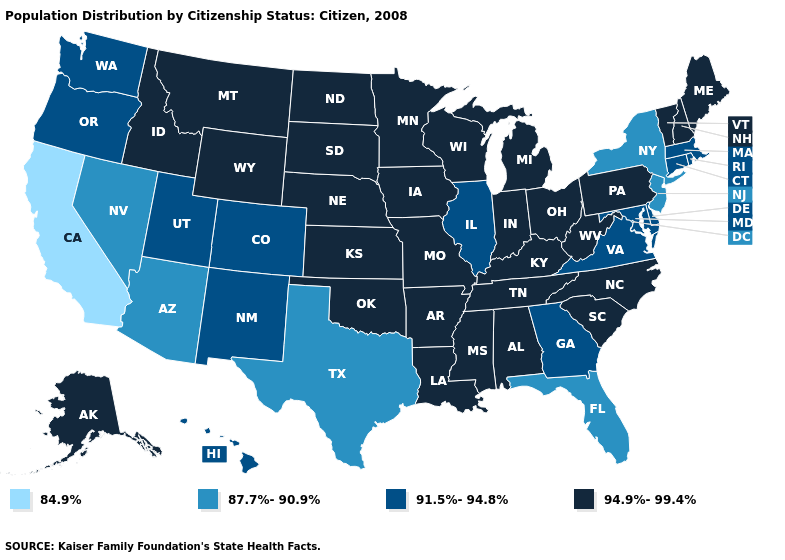Does South Dakota have the lowest value in the USA?
Write a very short answer. No. Does South Carolina have the same value as Alabama?
Be succinct. Yes. Name the states that have a value in the range 84.9%?
Keep it brief. California. Among the states that border Virginia , does Kentucky have the lowest value?
Be succinct. No. Name the states that have a value in the range 87.7%-90.9%?
Concise answer only. Arizona, Florida, Nevada, New Jersey, New York, Texas. What is the lowest value in states that border Florida?
Short answer required. 91.5%-94.8%. Name the states that have a value in the range 87.7%-90.9%?
Quick response, please. Arizona, Florida, Nevada, New Jersey, New York, Texas. What is the value of Arkansas?
Concise answer only. 94.9%-99.4%. Does Massachusetts have the highest value in the Northeast?
Short answer required. No. What is the value of Louisiana?
Give a very brief answer. 94.9%-99.4%. Name the states that have a value in the range 87.7%-90.9%?
Concise answer only. Arizona, Florida, Nevada, New Jersey, New York, Texas. Does Wisconsin have a higher value than New Mexico?
Give a very brief answer. Yes. What is the value of Mississippi?
Write a very short answer. 94.9%-99.4%. Name the states that have a value in the range 94.9%-99.4%?
Concise answer only. Alabama, Alaska, Arkansas, Idaho, Indiana, Iowa, Kansas, Kentucky, Louisiana, Maine, Michigan, Minnesota, Mississippi, Missouri, Montana, Nebraska, New Hampshire, North Carolina, North Dakota, Ohio, Oklahoma, Pennsylvania, South Carolina, South Dakota, Tennessee, Vermont, West Virginia, Wisconsin, Wyoming. Is the legend a continuous bar?
Short answer required. No. 